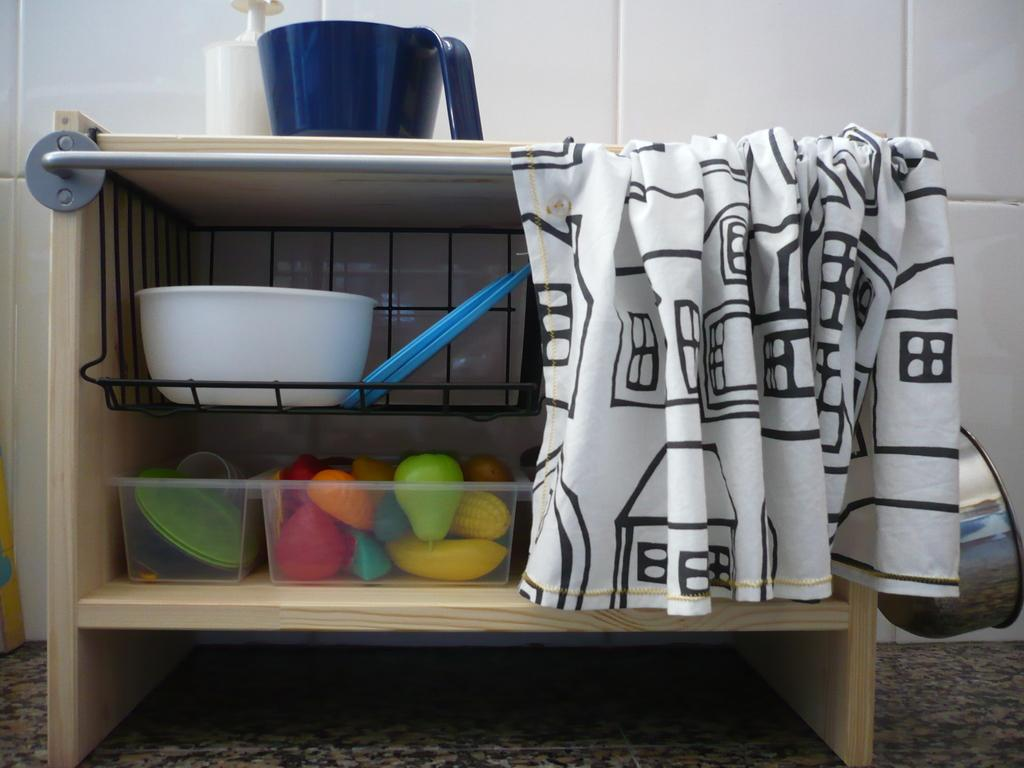What type of wooden object is shown in the image? The image shows the inside view of a wooden object. What can be found inside the wooden object? There is a bowl, toys, a towel, a rod, and other unspecified objects inside the wooden object. Can you describe the bowl in the wooden object? The bowl is located inside the wooden object. What is the purpose of the rod in the wooden object? The purpose of the rod in the wooden object is not specified in the image. How many pencils are visible in the image? There are no pencils visible in the image. Can you tell me how the wooden object helps the person sleep better? The image does not provide any information about the wooden object's ability to improve sleep. 